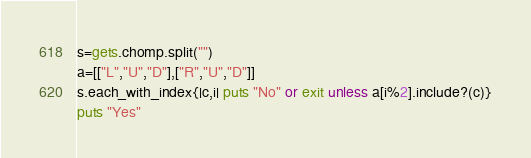Convert code to text. <code><loc_0><loc_0><loc_500><loc_500><_Ruby_>s=gets.chomp.split("")
a=[["L","U","D"],["R","U","D"]]
s.each_with_index{|c,i| puts "No" or exit unless a[i%2].include?(c)}
puts "Yes"</code> 